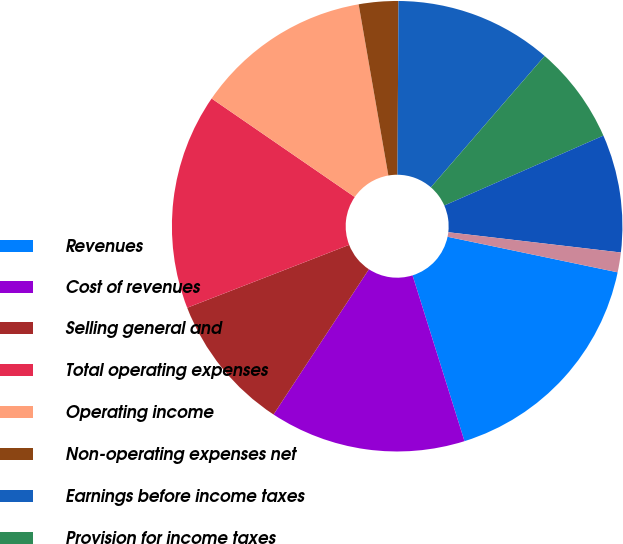Convert chart to OTSL. <chart><loc_0><loc_0><loc_500><loc_500><pie_chart><fcel>Revenues<fcel>Cost of revenues<fcel>Selling general and<fcel>Total operating expenses<fcel>Operating income<fcel>Non-operating expenses net<fcel>Earnings before income taxes<fcel>Provision for income taxes<fcel>Net earnings<fcel>Basic earnings per share<nl><fcel>16.89%<fcel>14.08%<fcel>9.86%<fcel>15.49%<fcel>12.67%<fcel>2.83%<fcel>11.27%<fcel>7.05%<fcel>8.45%<fcel>1.42%<nl></chart> 